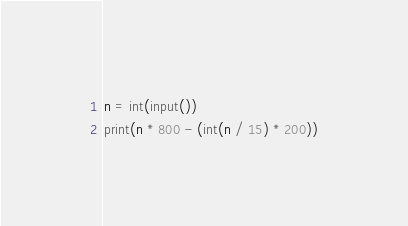Convert code to text. <code><loc_0><loc_0><loc_500><loc_500><_Python_>n = int(input())
print(n * 800 - (int(n / 15) * 200))</code> 